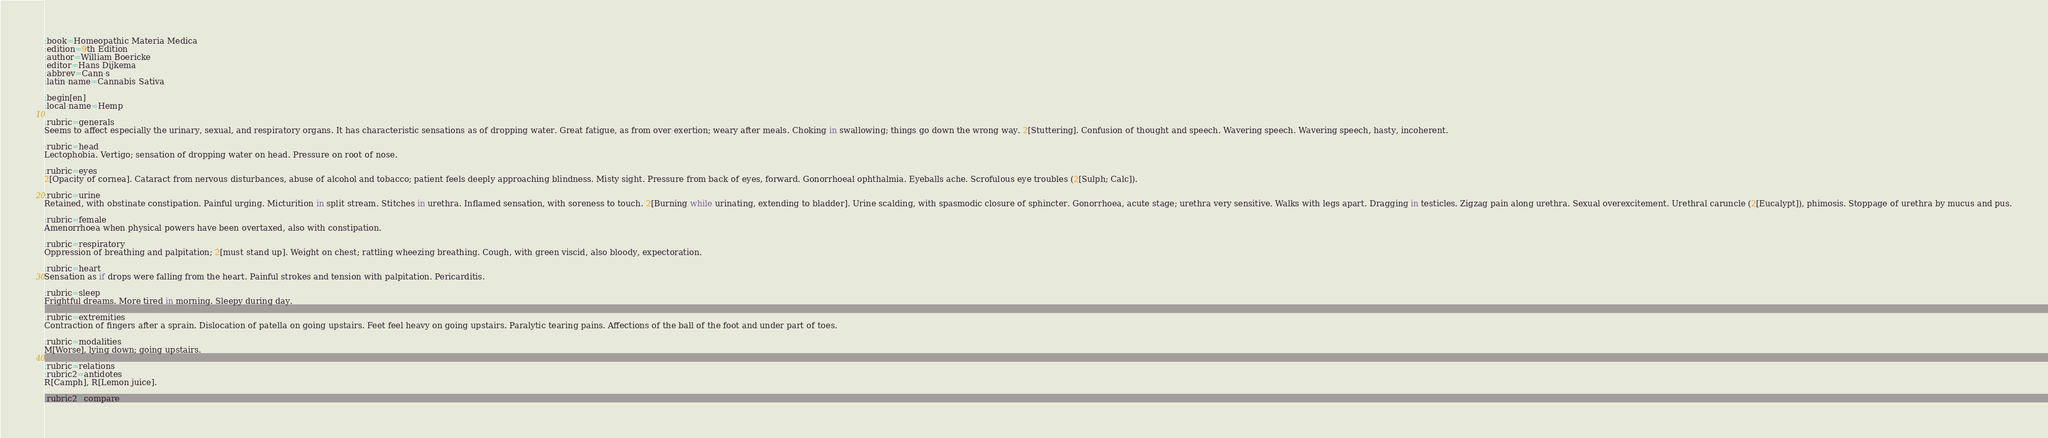Convert code to text. <code><loc_0><loc_0><loc_500><loc_500><_ObjectiveC_>:book=Homeopathic Materia Medica
:edition=9th Edition
:author=William Boericke
:editor=Hans Dijkema
:abbrev=Cann-s
:latin-name=Cannabis Sativa

:begin[en]
:local-name=Hemp

:rubric=generals
Seems to affect especially the urinary, sexual, and respiratory organs. It has characteristic sensations as of dropping water. Great fatigue, as from over-exertion; weary after meals. Choking in swallowing; things go down the wrong way. 2[Stuttering]. Confusion of thought and speech. Wavering speech. Wavering speech, hasty, incoherent.

:rubric=head
Lectophobia. Vertigo; sensation of dropping water on head. Pressure on root of nose.

:rubric=eyes
2[Opacity of cornea]. Cataract from nervous disturbances, abuse of alcohol and tobacco; patient feels deeply approaching blindness. Misty sight. Pressure from back of eyes, forward. Gonorrhoeal ophthalmia. Eyeballs ache. Scrofulous eye troubles (2[Sulph; Calc]).

:rubric=urine
Retained, with obstinate constipation. Painful urging. Micturition in split stream. Stitches in urethra. Inflamed sensation, with soreness to touch. 2[Burning while urinating, extending to bladder]. Urine scalding, with spasmodic closure of sphincter. Gonorrhoea, acute stage; urethra very sensitive. Walks with legs apart. Dragging in testicles. Zigzag pain along urethra. Sexual overexcitement. Urethral caruncle (2[Eucalypt]), phimosis. Stoppage of urethra by mucus and pus.

:rubric=female
Amenorrhoea when physical powers have been overtaxed, also with constipation.

:rubric=respiratory
Oppression of breathing and palpitation; 2[must stand up]. Weight on chest; rattling wheezing breathing. Cough, with green viscid, also bloody, expectoration.

:rubric=heart
Sensation as if drops were falling from the heart. Painful strokes and tension with palpitation. Pericarditis.

:rubric=sleep
Frightful dreams. More tired in morning. Sleepy during day.

:rubric=extremities
Contraction of fingers after a sprain. Dislocation of patella on going upstairs. Feet feel heavy on going upstairs. Paralytic tearing pains. Affections of the ball of the foot and under part of toes.

:rubric=modalities
M[Worse], lying down; going upstairs.

:rubric=relations
:rubric2=antidotes
R[Camph], R[Lemon juice].

:rubric2=compare</code> 